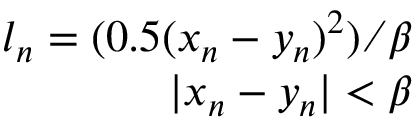Convert formula to latex. <formula><loc_0><loc_0><loc_500><loc_500>\begin{array} { r } { l _ { n } = ( 0 . 5 ( x _ { n } - y _ { n } ) ^ { 2 } ) \beta } \\ { | x _ { n } - y _ { n } | < \beta } \end{array}</formula> 